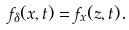Convert formula to latex. <formula><loc_0><loc_0><loc_500><loc_500>f _ { \delta } ( x , t ) = f _ { x } ( z , t ) .</formula> 